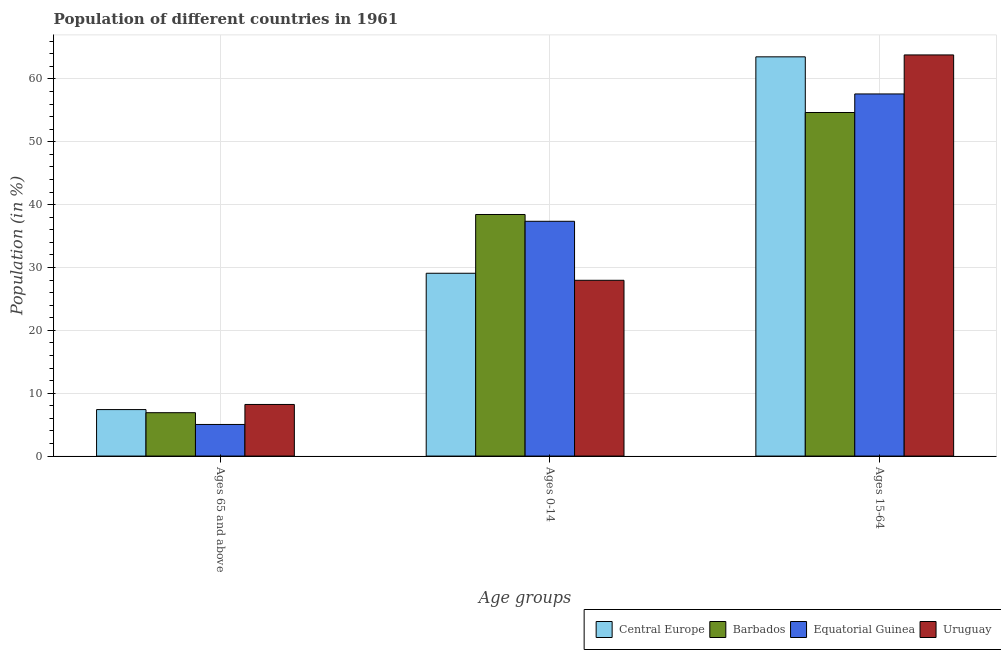How many different coloured bars are there?
Your answer should be compact. 4. Are the number of bars per tick equal to the number of legend labels?
Offer a terse response. Yes. How many bars are there on the 1st tick from the left?
Provide a succinct answer. 4. How many bars are there on the 2nd tick from the right?
Your answer should be compact. 4. What is the label of the 2nd group of bars from the left?
Ensure brevity in your answer.  Ages 0-14. What is the percentage of population within the age-group of 65 and above in Uruguay?
Your answer should be compact. 8.21. Across all countries, what is the maximum percentage of population within the age-group 0-14?
Ensure brevity in your answer.  38.44. Across all countries, what is the minimum percentage of population within the age-group 0-14?
Your answer should be very brief. 27.97. In which country was the percentage of population within the age-group 15-64 maximum?
Your answer should be compact. Uruguay. In which country was the percentage of population within the age-group 0-14 minimum?
Ensure brevity in your answer.  Uruguay. What is the total percentage of population within the age-group 15-64 in the graph?
Your answer should be compact. 239.62. What is the difference between the percentage of population within the age-group 15-64 in Central Europe and that in Uruguay?
Your response must be concise. -0.3. What is the difference between the percentage of population within the age-group 0-14 in Barbados and the percentage of population within the age-group 15-64 in Central Europe?
Ensure brevity in your answer.  -25.08. What is the average percentage of population within the age-group of 65 and above per country?
Provide a succinct answer. 6.88. What is the difference between the percentage of population within the age-group 15-64 and percentage of population within the age-group 0-14 in Barbados?
Your answer should be compact. 16.22. In how many countries, is the percentage of population within the age-group 15-64 greater than 2 %?
Your answer should be compact. 4. What is the ratio of the percentage of population within the age-group 15-64 in Barbados to that in Equatorial Guinea?
Your response must be concise. 0.95. Is the percentage of population within the age-group of 65 and above in Uruguay less than that in Central Europe?
Your answer should be compact. No. What is the difference between the highest and the second highest percentage of population within the age-group of 65 and above?
Your answer should be compact. 0.82. What is the difference between the highest and the lowest percentage of population within the age-group of 65 and above?
Your answer should be very brief. 3.18. What does the 2nd bar from the left in Ages 15-64 represents?
Offer a terse response. Barbados. What does the 3rd bar from the right in Ages 15-64 represents?
Provide a succinct answer. Barbados. How many bars are there?
Your answer should be very brief. 12. Are all the bars in the graph horizontal?
Provide a succinct answer. No. What is the difference between two consecutive major ticks on the Y-axis?
Your response must be concise. 10. Where does the legend appear in the graph?
Provide a succinct answer. Bottom right. How are the legend labels stacked?
Give a very brief answer. Horizontal. What is the title of the graph?
Your answer should be compact. Population of different countries in 1961. What is the label or title of the X-axis?
Ensure brevity in your answer.  Age groups. What is the label or title of the Y-axis?
Provide a short and direct response. Population (in %). What is the Population (in %) in Central Europe in Ages 65 and above?
Provide a short and direct response. 7.4. What is the Population (in %) of Barbados in Ages 65 and above?
Offer a very short reply. 6.9. What is the Population (in %) in Equatorial Guinea in Ages 65 and above?
Your response must be concise. 5.03. What is the Population (in %) of Uruguay in Ages 65 and above?
Your answer should be very brief. 8.21. What is the Population (in %) of Central Europe in Ages 0-14?
Offer a very short reply. 29.09. What is the Population (in %) in Barbados in Ages 0-14?
Your answer should be compact. 38.44. What is the Population (in %) of Equatorial Guinea in Ages 0-14?
Your answer should be compact. 37.36. What is the Population (in %) of Uruguay in Ages 0-14?
Keep it short and to the point. 27.97. What is the Population (in %) of Central Europe in Ages 15-64?
Provide a short and direct response. 63.52. What is the Population (in %) of Barbados in Ages 15-64?
Offer a very short reply. 54.66. What is the Population (in %) in Equatorial Guinea in Ages 15-64?
Keep it short and to the point. 57.62. What is the Population (in %) in Uruguay in Ages 15-64?
Provide a succinct answer. 63.82. Across all Age groups, what is the maximum Population (in %) in Central Europe?
Your answer should be very brief. 63.52. Across all Age groups, what is the maximum Population (in %) of Barbados?
Provide a succinct answer. 54.66. Across all Age groups, what is the maximum Population (in %) in Equatorial Guinea?
Provide a succinct answer. 57.62. Across all Age groups, what is the maximum Population (in %) of Uruguay?
Provide a short and direct response. 63.82. Across all Age groups, what is the minimum Population (in %) in Central Europe?
Give a very brief answer. 7.4. Across all Age groups, what is the minimum Population (in %) of Barbados?
Provide a short and direct response. 6.9. Across all Age groups, what is the minimum Population (in %) of Equatorial Guinea?
Provide a succinct answer. 5.03. Across all Age groups, what is the minimum Population (in %) in Uruguay?
Provide a short and direct response. 8.21. What is the total Population (in %) of Central Europe in the graph?
Ensure brevity in your answer.  100. What is the difference between the Population (in %) in Central Europe in Ages 65 and above and that in Ages 0-14?
Make the answer very short. -21.69. What is the difference between the Population (in %) of Barbados in Ages 65 and above and that in Ages 0-14?
Give a very brief answer. -31.54. What is the difference between the Population (in %) of Equatorial Guinea in Ages 65 and above and that in Ages 0-14?
Offer a terse response. -32.33. What is the difference between the Population (in %) of Uruguay in Ages 65 and above and that in Ages 0-14?
Your answer should be compact. -19.76. What is the difference between the Population (in %) of Central Europe in Ages 65 and above and that in Ages 15-64?
Offer a terse response. -56.12. What is the difference between the Population (in %) of Barbados in Ages 65 and above and that in Ages 15-64?
Keep it short and to the point. -47.76. What is the difference between the Population (in %) of Equatorial Guinea in Ages 65 and above and that in Ages 15-64?
Offer a very short reply. -52.59. What is the difference between the Population (in %) in Uruguay in Ages 65 and above and that in Ages 15-64?
Keep it short and to the point. -55.61. What is the difference between the Population (in %) of Central Europe in Ages 0-14 and that in Ages 15-64?
Your answer should be compact. -34.43. What is the difference between the Population (in %) in Barbados in Ages 0-14 and that in Ages 15-64?
Your answer should be very brief. -16.22. What is the difference between the Population (in %) in Equatorial Guinea in Ages 0-14 and that in Ages 15-64?
Provide a short and direct response. -20.26. What is the difference between the Population (in %) in Uruguay in Ages 0-14 and that in Ages 15-64?
Provide a short and direct response. -35.86. What is the difference between the Population (in %) in Central Europe in Ages 65 and above and the Population (in %) in Barbados in Ages 0-14?
Provide a short and direct response. -31.04. What is the difference between the Population (in %) in Central Europe in Ages 65 and above and the Population (in %) in Equatorial Guinea in Ages 0-14?
Offer a very short reply. -29.96. What is the difference between the Population (in %) of Central Europe in Ages 65 and above and the Population (in %) of Uruguay in Ages 0-14?
Give a very brief answer. -20.57. What is the difference between the Population (in %) in Barbados in Ages 65 and above and the Population (in %) in Equatorial Guinea in Ages 0-14?
Give a very brief answer. -30.45. What is the difference between the Population (in %) of Barbados in Ages 65 and above and the Population (in %) of Uruguay in Ages 0-14?
Offer a very short reply. -21.07. What is the difference between the Population (in %) of Equatorial Guinea in Ages 65 and above and the Population (in %) of Uruguay in Ages 0-14?
Your answer should be compact. -22.94. What is the difference between the Population (in %) in Central Europe in Ages 65 and above and the Population (in %) in Barbados in Ages 15-64?
Your answer should be compact. -47.27. What is the difference between the Population (in %) in Central Europe in Ages 65 and above and the Population (in %) in Equatorial Guinea in Ages 15-64?
Provide a short and direct response. -50.22. What is the difference between the Population (in %) of Central Europe in Ages 65 and above and the Population (in %) of Uruguay in Ages 15-64?
Offer a very short reply. -56.43. What is the difference between the Population (in %) in Barbados in Ages 65 and above and the Population (in %) in Equatorial Guinea in Ages 15-64?
Ensure brevity in your answer.  -50.72. What is the difference between the Population (in %) of Barbados in Ages 65 and above and the Population (in %) of Uruguay in Ages 15-64?
Provide a succinct answer. -56.92. What is the difference between the Population (in %) in Equatorial Guinea in Ages 65 and above and the Population (in %) in Uruguay in Ages 15-64?
Your answer should be compact. -58.8. What is the difference between the Population (in %) of Central Europe in Ages 0-14 and the Population (in %) of Barbados in Ages 15-64?
Offer a terse response. -25.58. What is the difference between the Population (in %) of Central Europe in Ages 0-14 and the Population (in %) of Equatorial Guinea in Ages 15-64?
Make the answer very short. -28.53. What is the difference between the Population (in %) of Central Europe in Ages 0-14 and the Population (in %) of Uruguay in Ages 15-64?
Ensure brevity in your answer.  -34.74. What is the difference between the Population (in %) of Barbados in Ages 0-14 and the Population (in %) of Equatorial Guinea in Ages 15-64?
Provide a short and direct response. -19.18. What is the difference between the Population (in %) of Barbados in Ages 0-14 and the Population (in %) of Uruguay in Ages 15-64?
Provide a succinct answer. -25.39. What is the difference between the Population (in %) in Equatorial Guinea in Ages 0-14 and the Population (in %) in Uruguay in Ages 15-64?
Your answer should be compact. -26.47. What is the average Population (in %) in Central Europe per Age groups?
Your answer should be very brief. 33.33. What is the average Population (in %) of Barbados per Age groups?
Provide a short and direct response. 33.33. What is the average Population (in %) in Equatorial Guinea per Age groups?
Your answer should be very brief. 33.33. What is the average Population (in %) of Uruguay per Age groups?
Your response must be concise. 33.33. What is the difference between the Population (in %) in Central Europe and Population (in %) in Barbados in Ages 65 and above?
Your answer should be compact. 0.49. What is the difference between the Population (in %) in Central Europe and Population (in %) in Equatorial Guinea in Ages 65 and above?
Your answer should be very brief. 2.37. What is the difference between the Population (in %) in Central Europe and Population (in %) in Uruguay in Ages 65 and above?
Keep it short and to the point. -0.82. What is the difference between the Population (in %) in Barbados and Population (in %) in Equatorial Guinea in Ages 65 and above?
Ensure brevity in your answer.  1.87. What is the difference between the Population (in %) of Barbados and Population (in %) of Uruguay in Ages 65 and above?
Your answer should be very brief. -1.31. What is the difference between the Population (in %) of Equatorial Guinea and Population (in %) of Uruguay in Ages 65 and above?
Ensure brevity in your answer.  -3.18. What is the difference between the Population (in %) of Central Europe and Population (in %) of Barbados in Ages 0-14?
Offer a very short reply. -9.35. What is the difference between the Population (in %) in Central Europe and Population (in %) in Equatorial Guinea in Ages 0-14?
Make the answer very short. -8.27. What is the difference between the Population (in %) in Central Europe and Population (in %) in Uruguay in Ages 0-14?
Give a very brief answer. 1.12. What is the difference between the Population (in %) in Barbados and Population (in %) in Equatorial Guinea in Ages 0-14?
Your response must be concise. 1.08. What is the difference between the Population (in %) in Barbados and Population (in %) in Uruguay in Ages 0-14?
Offer a terse response. 10.47. What is the difference between the Population (in %) in Equatorial Guinea and Population (in %) in Uruguay in Ages 0-14?
Your answer should be very brief. 9.39. What is the difference between the Population (in %) of Central Europe and Population (in %) of Barbados in Ages 15-64?
Provide a succinct answer. 8.86. What is the difference between the Population (in %) of Central Europe and Population (in %) of Equatorial Guinea in Ages 15-64?
Keep it short and to the point. 5.9. What is the difference between the Population (in %) in Central Europe and Population (in %) in Uruguay in Ages 15-64?
Offer a terse response. -0.3. What is the difference between the Population (in %) of Barbados and Population (in %) of Equatorial Guinea in Ages 15-64?
Your answer should be compact. -2.95. What is the difference between the Population (in %) of Barbados and Population (in %) of Uruguay in Ages 15-64?
Make the answer very short. -9.16. What is the difference between the Population (in %) in Equatorial Guinea and Population (in %) in Uruguay in Ages 15-64?
Your answer should be very brief. -6.21. What is the ratio of the Population (in %) in Central Europe in Ages 65 and above to that in Ages 0-14?
Give a very brief answer. 0.25. What is the ratio of the Population (in %) in Barbados in Ages 65 and above to that in Ages 0-14?
Offer a very short reply. 0.18. What is the ratio of the Population (in %) of Equatorial Guinea in Ages 65 and above to that in Ages 0-14?
Your answer should be compact. 0.13. What is the ratio of the Population (in %) of Uruguay in Ages 65 and above to that in Ages 0-14?
Your answer should be compact. 0.29. What is the ratio of the Population (in %) in Central Europe in Ages 65 and above to that in Ages 15-64?
Provide a short and direct response. 0.12. What is the ratio of the Population (in %) in Barbados in Ages 65 and above to that in Ages 15-64?
Your answer should be very brief. 0.13. What is the ratio of the Population (in %) in Equatorial Guinea in Ages 65 and above to that in Ages 15-64?
Make the answer very short. 0.09. What is the ratio of the Population (in %) of Uruguay in Ages 65 and above to that in Ages 15-64?
Provide a short and direct response. 0.13. What is the ratio of the Population (in %) of Central Europe in Ages 0-14 to that in Ages 15-64?
Give a very brief answer. 0.46. What is the ratio of the Population (in %) in Barbados in Ages 0-14 to that in Ages 15-64?
Provide a short and direct response. 0.7. What is the ratio of the Population (in %) in Equatorial Guinea in Ages 0-14 to that in Ages 15-64?
Provide a short and direct response. 0.65. What is the ratio of the Population (in %) in Uruguay in Ages 0-14 to that in Ages 15-64?
Offer a very short reply. 0.44. What is the difference between the highest and the second highest Population (in %) of Central Europe?
Keep it short and to the point. 34.43. What is the difference between the highest and the second highest Population (in %) of Barbados?
Your response must be concise. 16.22. What is the difference between the highest and the second highest Population (in %) of Equatorial Guinea?
Your answer should be very brief. 20.26. What is the difference between the highest and the second highest Population (in %) of Uruguay?
Keep it short and to the point. 35.86. What is the difference between the highest and the lowest Population (in %) in Central Europe?
Offer a very short reply. 56.12. What is the difference between the highest and the lowest Population (in %) of Barbados?
Provide a succinct answer. 47.76. What is the difference between the highest and the lowest Population (in %) of Equatorial Guinea?
Offer a very short reply. 52.59. What is the difference between the highest and the lowest Population (in %) of Uruguay?
Give a very brief answer. 55.61. 